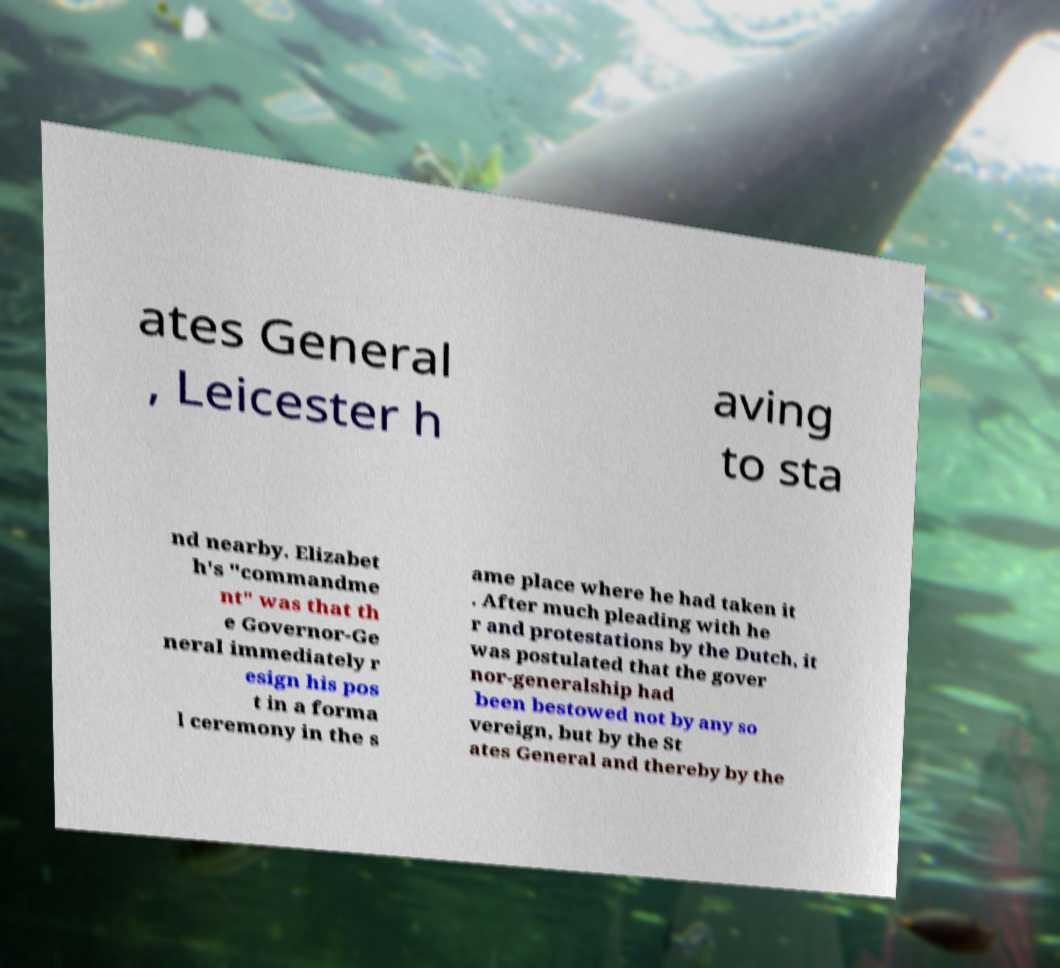Please identify and transcribe the text found in this image. ates General , Leicester h aving to sta nd nearby. Elizabet h's "commandme nt" was that th e Governor-Ge neral immediately r esign his pos t in a forma l ceremony in the s ame place where he had taken it . After much pleading with he r and protestations by the Dutch, it was postulated that the gover nor-generalship had been bestowed not by any so vereign, but by the St ates General and thereby by the 